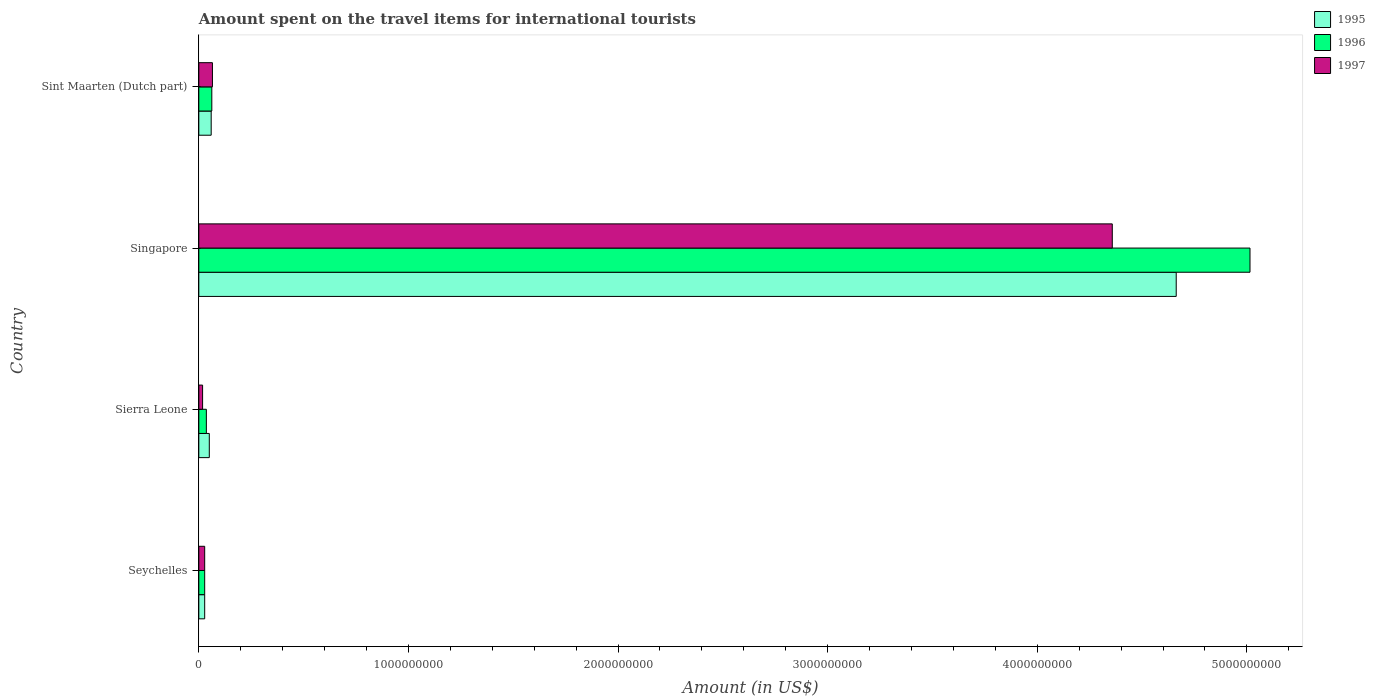How many different coloured bars are there?
Your answer should be compact. 3. How many groups of bars are there?
Offer a very short reply. 4. Are the number of bars per tick equal to the number of legend labels?
Ensure brevity in your answer.  Yes. How many bars are there on the 4th tick from the top?
Offer a terse response. 3. What is the label of the 3rd group of bars from the top?
Your answer should be very brief. Sierra Leone. What is the amount spent on the travel items for international tourists in 1996 in Sint Maarten (Dutch part)?
Keep it short and to the point. 6.20e+07. Across all countries, what is the maximum amount spent on the travel items for international tourists in 1996?
Ensure brevity in your answer.  5.02e+09. Across all countries, what is the minimum amount spent on the travel items for international tourists in 1997?
Your answer should be compact. 1.80e+07. In which country was the amount spent on the travel items for international tourists in 1995 maximum?
Provide a succinct answer. Singapore. In which country was the amount spent on the travel items for international tourists in 1995 minimum?
Ensure brevity in your answer.  Seychelles. What is the total amount spent on the travel items for international tourists in 1995 in the graph?
Give a very brief answer. 4.80e+09. What is the difference between the amount spent on the travel items for international tourists in 1997 in Singapore and that in Sint Maarten (Dutch part)?
Give a very brief answer. 4.29e+09. What is the difference between the amount spent on the travel items for international tourists in 1996 in Sierra Leone and the amount spent on the travel items for international tourists in 1995 in Singapore?
Provide a succinct answer. -4.63e+09. What is the average amount spent on the travel items for international tourists in 1996 per country?
Your response must be concise. 1.29e+09. What is the difference between the amount spent on the travel items for international tourists in 1997 and amount spent on the travel items for international tourists in 1995 in Sierra Leone?
Your answer should be compact. -3.20e+07. In how many countries, is the amount spent on the travel items for international tourists in 1995 greater than 2600000000 US$?
Provide a succinct answer. 1. What is the ratio of the amount spent on the travel items for international tourists in 1997 in Seychelles to that in Sint Maarten (Dutch part)?
Provide a short and direct response. 0.43. Is the amount spent on the travel items for international tourists in 1997 in Sierra Leone less than that in Sint Maarten (Dutch part)?
Provide a succinct answer. Yes. What is the difference between the highest and the second highest amount spent on the travel items for international tourists in 1997?
Your answer should be compact. 4.29e+09. What is the difference between the highest and the lowest amount spent on the travel items for international tourists in 1995?
Your answer should be very brief. 4.64e+09. In how many countries, is the amount spent on the travel items for international tourists in 1995 greater than the average amount spent on the travel items for international tourists in 1995 taken over all countries?
Your response must be concise. 1. What does the 3rd bar from the top in Sint Maarten (Dutch part) represents?
Your response must be concise. 1995. What does the 3rd bar from the bottom in Seychelles represents?
Offer a terse response. 1997. How many bars are there?
Your response must be concise. 12. Are all the bars in the graph horizontal?
Provide a succinct answer. Yes. How many countries are there in the graph?
Offer a terse response. 4. Does the graph contain any zero values?
Your answer should be very brief. No. Does the graph contain grids?
Keep it short and to the point. No. What is the title of the graph?
Your response must be concise. Amount spent on the travel items for international tourists. Does "2010" appear as one of the legend labels in the graph?
Your answer should be compact. No. What is the label or title of the Y-axis?
Offer a very short reply. Country. What is the Amount (in US$) of 1995 in Seychelles?
Your response must be concise. 2.80e+07. What is the Amount (in US$) in 1996 in Seychelles?
Keep it short and to the point. 2.80e+07. What is the Amount (in US$) in 1997 in Seychelles?
Provide a short and direct response. 2.80e+07. What is the Amount (in US$) of 1996 in Sierra Leone?
Ensure brevity in your answer.  3.60e+07. What is the Amount (in US$) in 1997 in Sierra Leone?
Provide a succinct answer. 1.80e+07. What is the Amount (in US$) of 1995 in Singapore?
Offer a terse response. 4.66e+09. What is the Amount (in US$) in 1996 in Singapore?
Give a very brief answer. 5.02e+09. What is the Amount (in US$) of 1997 in Singapore?
Give a very brief answer. 4.36e+09. What is the Amount (in US$) in 1995 in Sint Maarten (Dutch part)?
Your response must be concise. 5.90e+07. What is the Amount (in US$) of 1996 in Sint Maarten (Dutch part)?
Keep it short and to the point. 6.20e+07. What is the Amount (in US$) of 1997 in Sint Maarten (Dutch part)?
Offer a terse response. 6.50e+07. Across all countries, what is the maximum Amount (in US$) of 1995?
Give a very brief answer. 4.66e+09. Across all countries, what is the maximum Amount (in US$) of 1996?
Give a very brief answer. 5.02e+09. Across all countries, what is the maximum Amount (in US$) in 1997?
Keep it short and to the point. 4.36e+09. Across all countries, what is the minimum Amount (in US$) in 1995?
Ensure brevity in your answer.  2.80e+07. Across all countries, what is the minimum Amount (in US$) in 1996?
Provide a short and direct response. 2.80e+07. Across all countries, what is the minimum Amount (in US$) of 1997?
Ensure brevity in your answer.  1.80e+07. What is the total Amount (in US$) of 1995 in the graph?
Offer a terse response. 4.80e+09. What is the total Amount (in US$) in 1996 in the graph?
Keep it short and to the point. 5.14e+09. What is the total Amount (in US$) in 1997 in the graph?
Provide a short and direct response. 4.47e+09. What is the difference between the Amount (in US$) of 1995 in Seychelles and that in Sierra Leone?
Ensure brevity in your answer.  -2.20e+07. What is the difference between the Amount (in US$) in 1996 in Seychelles and that in Sierra Leone?
Keep it short and to the point. -8.00e+06. What is the difference between the Amount (in US$) in 1997 in Seychelles and that in Sierra Leone?
Provide a short and direct response. 1.00e+07. What is the difference between the Amount (in US$) of 1995 in Seychelles and that in Singapore?
Keep it short and to the point. -4.64e+09. What is the difference between the Amount (in US$) in 1996 in Seychelles and that in Singapore?
Keep it short and to the point. -4.99e+09. What is the difference between the Amount (in US$) of 1997 in Seychelles and that in Singapore?
Keep it short and to the point. -4.33e+09. What is the difference between the Amount (in US$) of 1995 in Seychelles and that in Sint Maarten (Dutch part)?
Offer a very short reply. -3.10e+07. What is the difference between the Amount (in US$) in 1996 in Seychelles and that in Sint Maarten (Dutch part)?
Your response must be concise. -3.40e+07. What is the difference between the Amount (in US$) in 1997 in Seychelles and that in Sint Maarten (Dutch part)?
Ensure brevity in your answer.  -3.70e+07. What is the difference between the Amount (in US$) in 1995 in Sierra Leone and that in Singapore?
Your answer should be very brief. -4.61e+09. What is the difference between the Amount (in US$) of 1996 in Sierra Leone and that in Singapore?
Keep it short and to the point. -4.98e+09. What is the difference between the Amount (in US$) in 1997 in Sierra Leone and that in Singapore?
Keep it short and to the point. -4.34e+09. What is the difference between the Amount (in US$) in 1995 in Sierra Leone and that in Sint Maarten (Dutch part)?
Provide a short and direct response. -9.00e+06. What is the difference between the Amount (in US$) of 1996 in Sierra Leone and that in Sint Maarten (Dutch part)?
Your answer should be very brief. -2.60e+07. What is the difference between the Amount (in US$) of 1997 in Sierra Leone and that in Sint Maarten (Dutch part)?
Ensure brevity in your answer.  -4.70e+07. What is the difference between the Amount (in US$) in 1995 in Singapore and that in Sint Maarten (Dutch part)?
Give a very brief answer. 4.60e+09. What is the difference between the Amount (in US$) in 1996 in Singapore and that in Sint Maarten (Dutch part)?
Provide a short and direct response. 4.95e+09. What is the difference between the Amount (in US$) in 1997 in Singapore and that in Sint Maarten (Dutch part)?
Make the answer very short. 4.29e+09. What is the difference between the Amount (in US$) of 1995 in Seychelles and the Amount (in US$) of 1996 in Sierra Leone?
Your answer should be compact. -8.00e+06. What is the difference between the Amount (in US$) of 1995 in Seychelles and the Amount (in US$) of 1997 in Sierra Leone?
Offer a very short reply. 1.00e+07. What is the difference between the Amount (in US$) in 1995 in Seychelles and the Amount (in US$) in 1996 in Singapore?
Provide a succinct answer. -4.99e+09. What is the difference between the Amount (in US$) of 1995 in Seychelles and the Amount (in US$) of 1997 in Singapore?
Provide a succinct answer. -4.33e+09. What is the difference between the Amount (in US$) in 1996 in Seychelles and the Amount (in US$) in 1997 in Singapore?
Keep it short and to the point. -4.33e+09. What is the difference between the Amount (in US$) of 1995 in Seychelles and the Amount (in US$) of 1996 in Sint Maarten (Dutch part)?
Give a very brief answer. -3.40e+07. What is the difference between the Amount (in US$) of 1995 in Seychelles and the Amount (in US$) of 1997 in Sint Maarten (Dutch part)?
Your response must be concise. -3.70e+07. What is the difference between the Amount (in US$) of 1996 in Seychelles and the Amount (in US$) of 1997 in Sint Maarten (Dutch part)?
Offer a very short reply. -3.70e+07. What is the difference between the Amount (in US$) of 1995 in Sierra Leone and the Amount (in US$) of 1996 in Singapore?
Offer a very short reply. -4.96e+09. What is the difference between the Amount (in US$) in 1995 in Sierra Leone and the Amount (in US$) in 1997 in Singapore?
Ensure brevity in your answer.  -4.31e+09. What is the difference between the Amount (in US$) in 1996 in Sierra Leone and the Amount (in US$) in 1997 in Singapore?
Provide a succinct answer. -4.32e+09. What is the difference between the Amount (in US$) in 1995 in Sierra Leone and the Amount (in US$) in 1996 in Sint Maarten (Dutch part)?
Provide a short and direct response. -1.20e+07. What is the difference between the Amount (in US$) of 1995 in Sierra Leone and the Amount (in US$) of 1997 in Sint Maarten (Dutch part)?
Give a very brief answer. -1.50e+07. What is the difference between the Amount (in US$) in 1996 in Sierra Leone and the Amount (in US$) in 1997 in Sint Maarten (Dutch part)?
Your response must be concise. -2.90e+07. What is the difference between the Amount (in US$) in 1995 in Singapore and the Amount (in US$) in 1996 in Sint Maarten (Dutch part)?
Your response must be concise. 4.60e+09. What is the difference between the Amount (in US$) in 1995 in Singapore and the Amount (in US$) in 1997 in Sint Maarten (Dutch part)?
Offer a very short reply. 4.60e+09. What is the difference between the Amount (in US$) in 1996 in Singapore and the Amount (in US$) in 1997 in Sint Maarten (Dutch part)?
Ensure brevity in your answer.  4.95e+09. What is the average Amount (in US$) in 1995 per country?
Keep it short and to the point. 1.20e+09. What is the average Amount (in US$) in 1996 per country?
Provide a short and direct response. 1.29e+09. What is the average Amount (in US$) of 1997 per country?
Your answer should be compact. 1.12e+09. What is the difference between the Amount (in US$) in 1996 and Amount (in US$) in 1997 in Seychelles?
Give a very brief answer. 0. What is the difference between the Amount (in US$) in 1995 and Amount (in US$) in 1996 in Sierra Leone?
Offer a terse response. 1.40e+07. What is the difference between the Amount (in US$) in 1995 and Amount (in US$) in 1997 in Sierra Leone?
Give a very brief answer. 3.20e+07. What is the difference between the Amount (in US$) of 1996 and Amount (in US$) of 1997 in Sierra Leone?
Provide a short and direct response. 1.80e+07. What is the difference between the Amount (in US$) in 1995 and Amount (in US$) in 1996 in Singapore?
Give a very brief answer. -3.52e+08. What is the difference between the Amount (in US$) of 1995 and Amount (in US$) of 1997 in Singapore?
Provide a short and direct response. 3.05e+08. What is the difference between the Amount (in US$) in 1996 and Amount (in US$) in 1997 in Singapore?
Keep it short and to the point. 6.57e+08. What is the difference between the Amount (in US$) in 1995 and Amount (in US$) in 1996 in Sint Maarten (Dutch part)?
Your answer should be very brief. -3.00e+06. What is the difference between the Amount (in US$) in 1995 and Amount (in US$) in 1997 in Sint Maarten (Dutch part)?
Your answer should be very brief. -6.00e+06. What is the difference between the Amount (in US$) of 1996 and Amount (in US$) of 1997 in Sint Maarten (Dutch part)?
Offer a very short reply. -3.00e+06. What is the ratio of the Amount (in US$) of 1995 in Seychelles to that in Sierra Leone?
Provide a short and direct response. 0.56. What is the ratio of the Amount (in US$) in 1997 in Seychelles to that in Sierra Leone?
Make the answer very short. 1.56. What is the ratio of the Amount (in US$) in 1995 in Seychelles to that in Singapore?
Your response must be concise. 0.01. What is the ratio of the Amount (in US$) in 1996 in Seychelles to that in Singapore?
Make the answer very short. 0.01. What is the ratio of the Amount (in US$) in 1997 in Seychelles to that in Singapore?
Provide a short and direct response. 0.01. What is the ratio of the Amount (in US$) of 1995 in Seychelles to that in Sint Maarten (Dutch part)?
Your answer should be compact. 0.47. What is the ratio of the Amount (in US$) in 1996 in Seychelles to that in Sint Maarten (Dutch part)?
Provide a short and direct response. 0.45. What is the ratio of the Amount (in US$) of 1997 in Seychelles to that in Sint Maarten (Dutch part)?
Your response must be concise. 0.43. What is the ratio of the Amount (in US$) of 1995 in Sierra Leone to that in Singapore?
Ensure brevity in your answer.  0.01. What is the ratio of the Amount (in US$) of 1996 in Sierra Leone to that in Singapore?
Your response must be concise. 0.01. What is the ratio of the Amount (in US$) in 1997 in Sierra Leone to that in Singapore?
Keep it short and to the point. 0. What is the ratio of the Amount (in US$) of 1995 in Sierra Leone to that in Sint Maarten (Dutch part)?
Ensure brevity in your answer.  0.85. What is the ratio of the Amount (in US$) in 1996 in Sierra Leone to that in Sint Maarten (Dutch part)?
Provide a short and direct response. 0.58. What is the ratio of the Amount (in US$) in 1997 in Sierra Leone to that in Sint Maarten (Dutch part)?
Your answer should be very brief. 0.28. What is the ratio of the Amount (in US$) of 1995 in Singapore to that in Sint Maarten (Dutch part)?
Provide a short and direct response. 79.03. What is the ratio of the Amount (in US$) in 1996 in Singapore to that in Sint Maarten (Dutch part)?
Your response must be concise. 80.89. What is the ratio of the Amount (in US$) of 1997 in Singapore to that in Sint Maarten (Dutch part)?
Provide a short and direct response. 67.05. What is the difference between the highest and the second highest Amount (in US$) of 1995?
Offer a very short reply. 4.60e+09. What is the difference between the highest and the second highest Amount (in US$) in 1996?
Provide a short and direct response. 4.95e+09. What is the difference between the highest and the second highest Amount (in US$) of 1997?
Keep it short and to the point. 4.29e+09. What is the difference between the highest and the lowest Amount (in US$) in 1995?
Keep it short and to the point. 4.64e+09. What is the difference between the highest and the lowest Amount (in US$) of 1996?
Offer a terse response. 4.99e+09. What is the difference between the highest and the lowest Amount (in US$) of 1997?
Your answer should be very brief. 4.34e+09. 